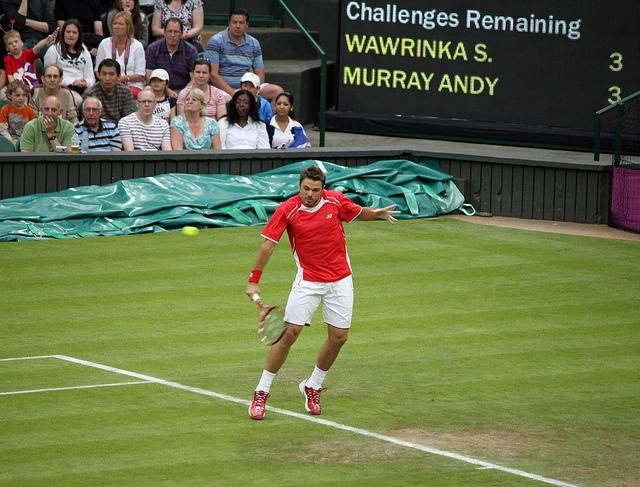What type of sign is shown? scoreboard 